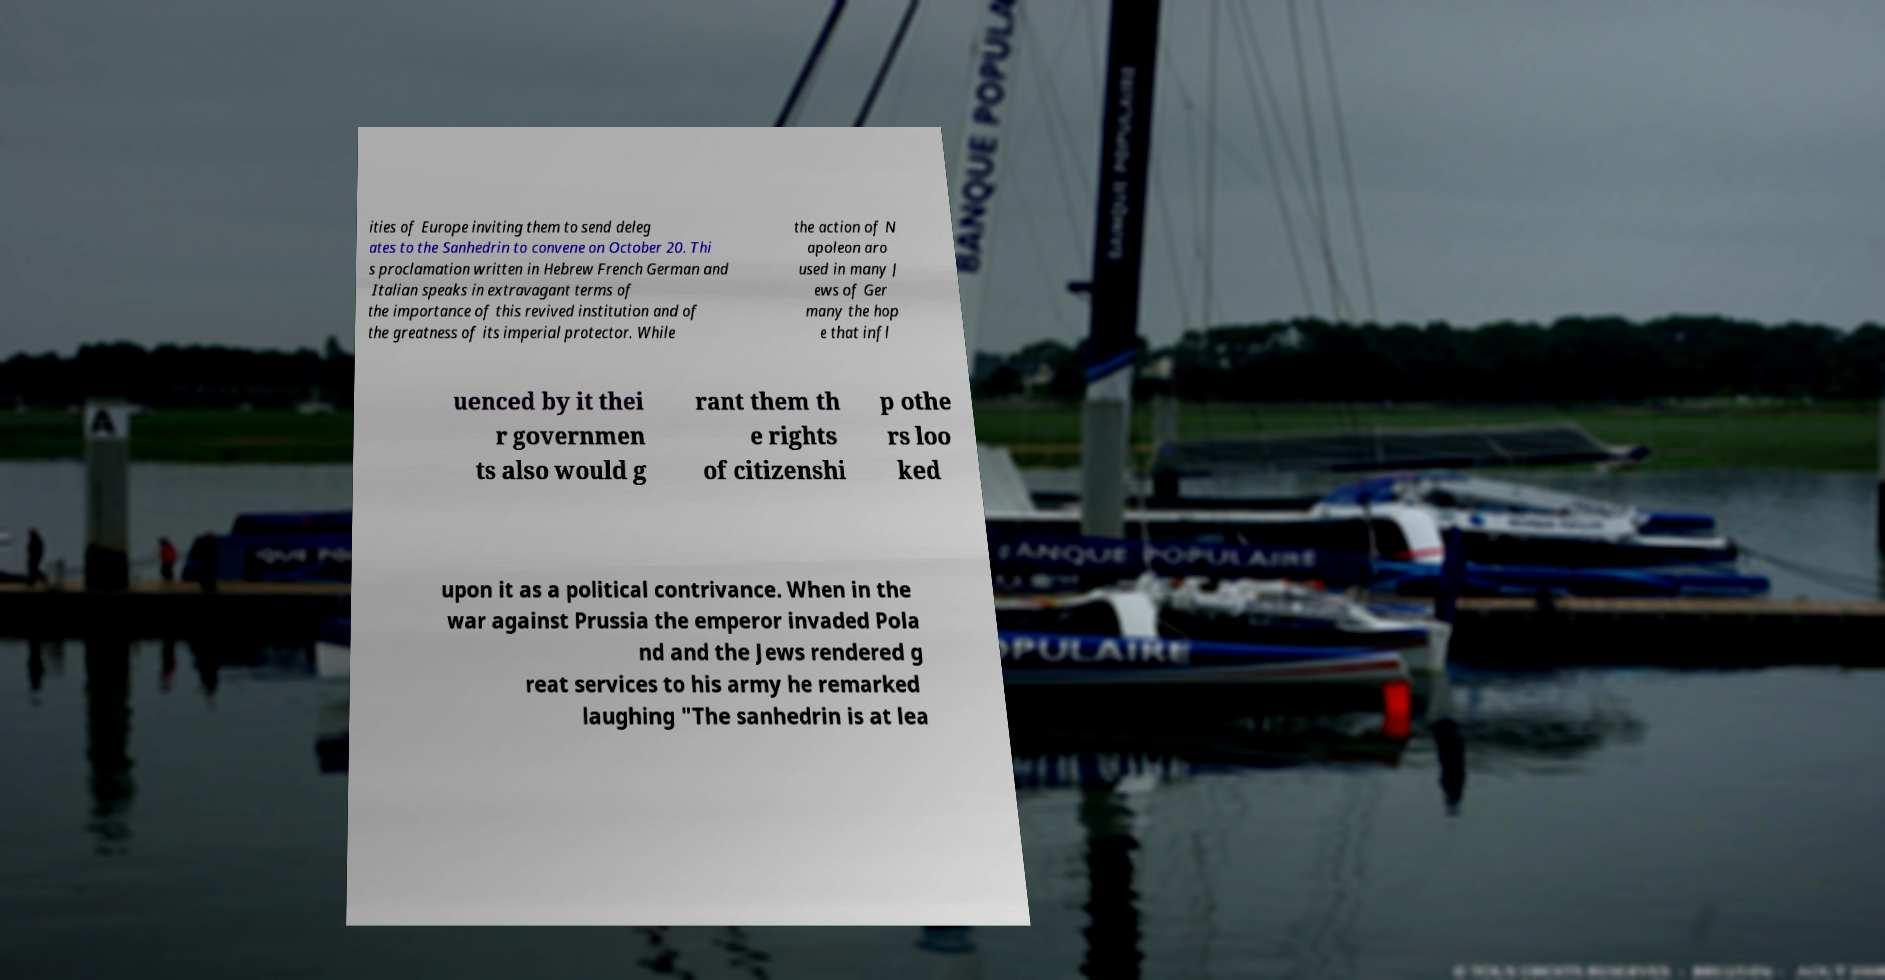Please identify and transcribe the text found in this image. ities of Europe inviting them to send deleg ates to the Sanhedrin to convene on October 20. Thi s proclamation written in Hebrew French German and Italian speaks in extravagant terms of the importance of this revived institution and of the greatness of its imperial protector. While the action of N apoleon aro used in many J ews of Ger many the hop e that infl uenced by it thei r governmen ts also would g rant them th e rights of citizenshi p othe rs loo ked upon it as a political contrivance. When in the war against Prussia the emperor invaded Pola nd and the Jews rendered g reat services to his army he remarked laughing "The sanhedrin is at lea 